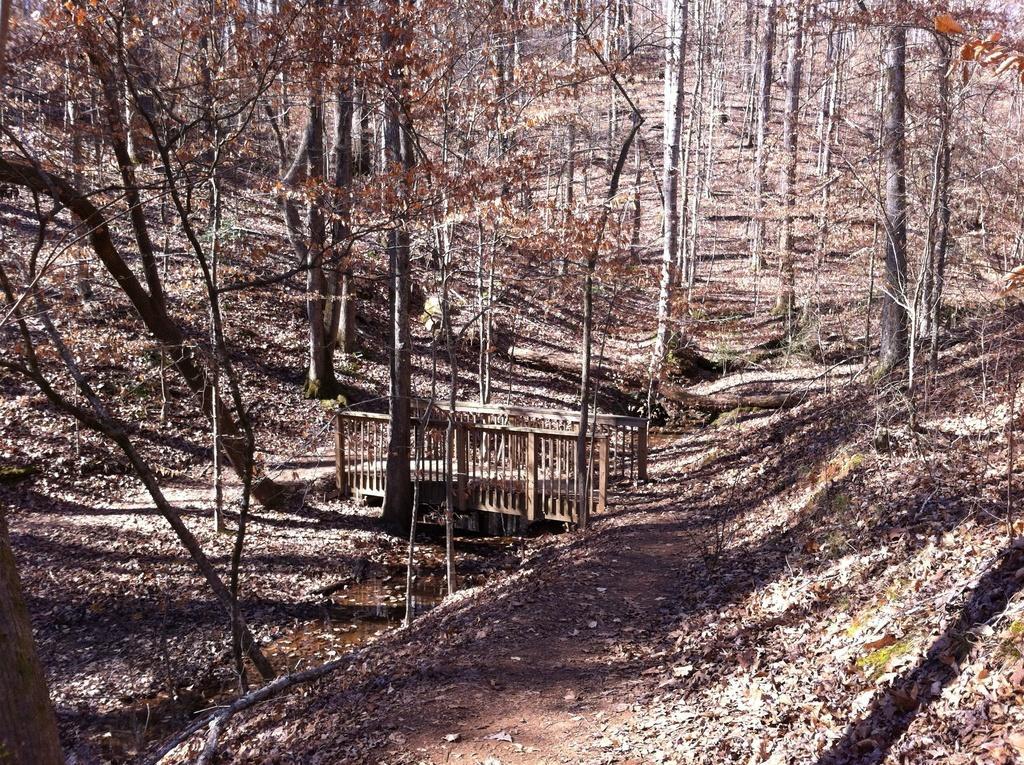Can you describe this image briefly? In this image we can see trees. There is a wooden bridge. There are dried leaves at the bottom of the image. 